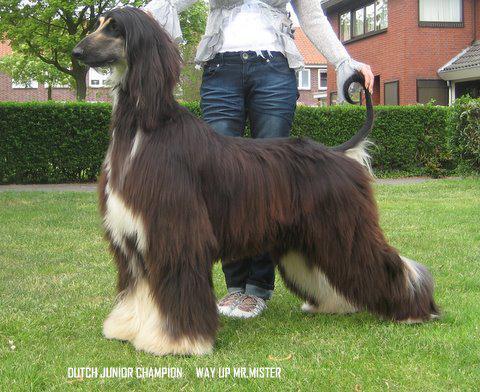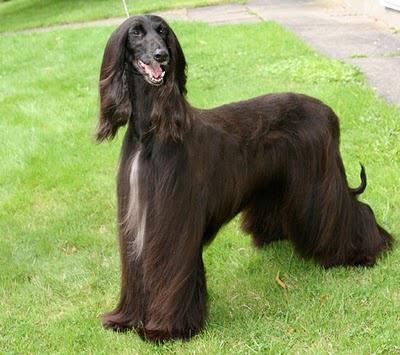The first image is the image on the left, the second image is the image on the right. Evaluate the accuracy of this statement regarding the images: "One of the images contains two of the afghan hounds.". Is it true? Answer yes or no. No. The first image is the image on the left, the second image is the image on the right. Evaluate the accuracy of this statement regarding the images: "There are two Afghan Hounds outside in the right image.". Is it true? Answer yes or no. No. 